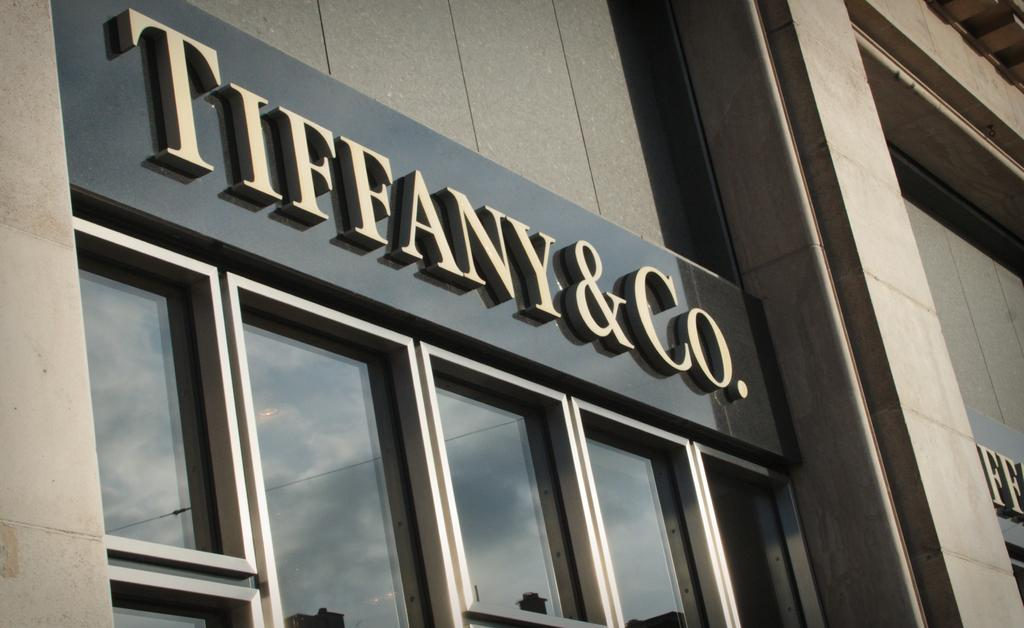What type of material is used for the windows in the image? The windows in the image are made of glass. What can be seen attached to the wall of a building in the image? There is a text board attached to the wall of a building in the image. What type of quilt is draped over the text board in the image? There is no quilt present in the image; it only features a text board attached to the wall of a building. Can you describe the curve of the text board in the image? The text board in the image is not described as having a curve, so it is not possible to answer that question. 